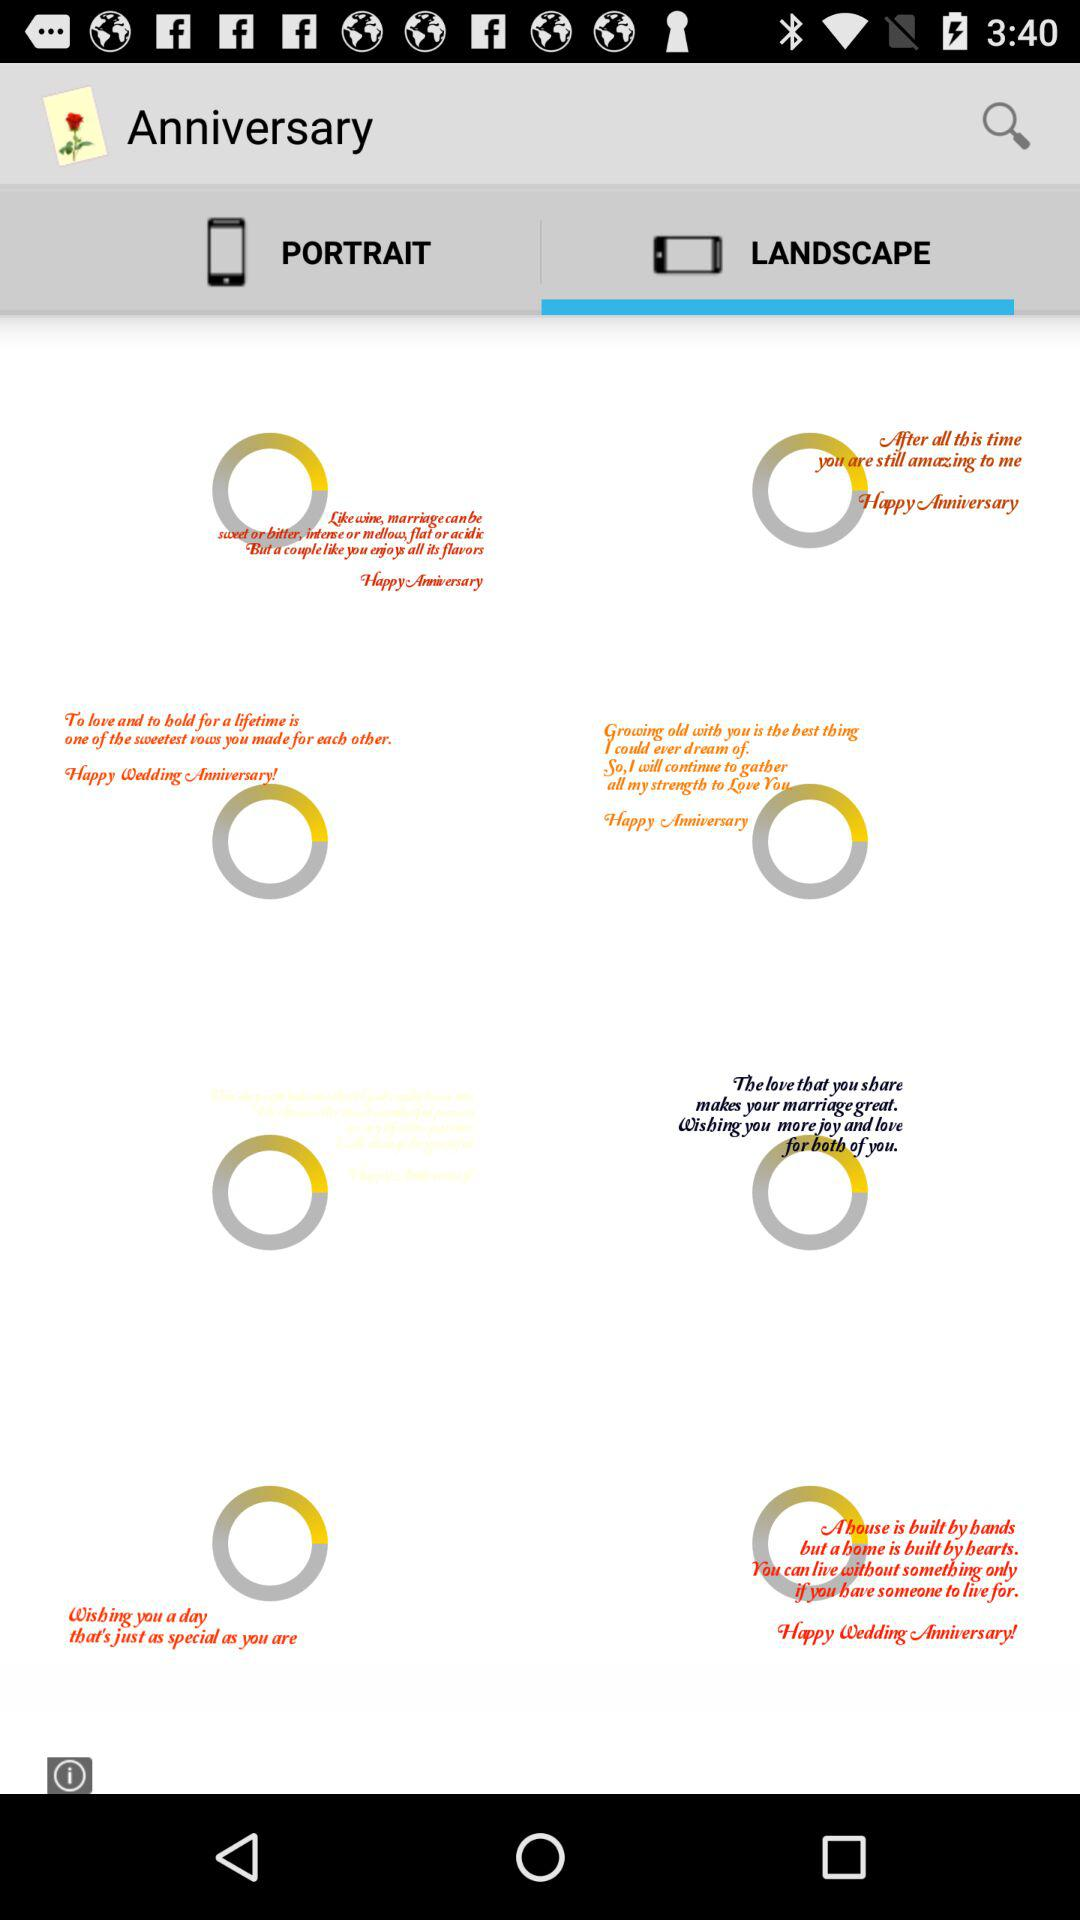Which tab is open? The open tab is "LANDSCAPE". 